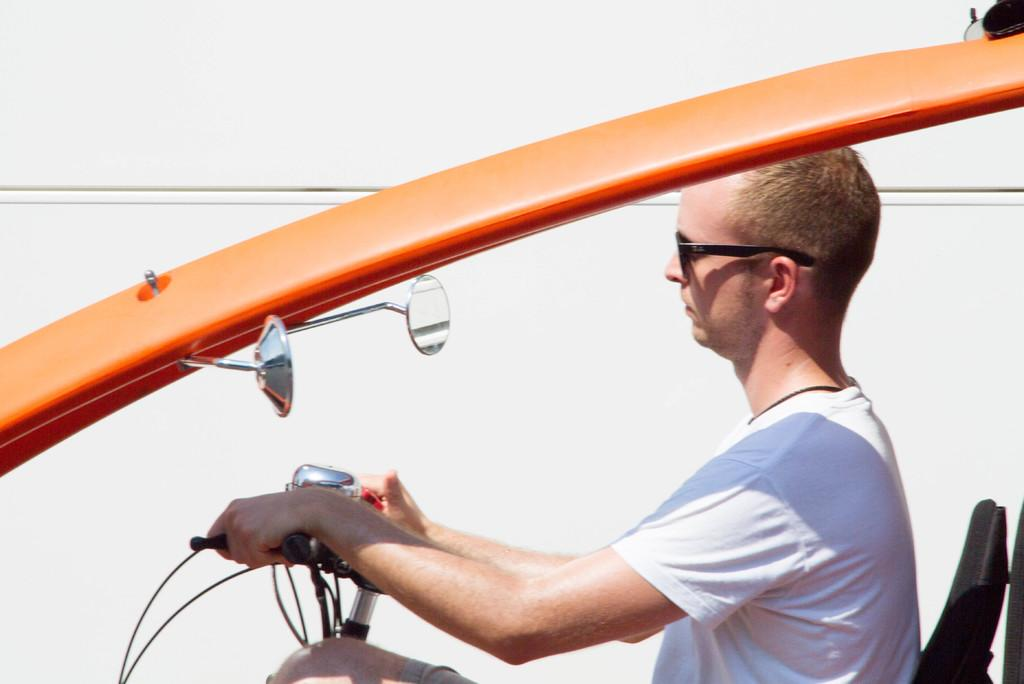What is the main subject of the image? The main subject of the image is a man. What is the man doing in the image? The man is driving a vehicle. What feature can be seen in the middle of the vehicle? There is a handle in the middle of the vehicle. How many mirrors are present in the middle of the vehicle? There are two mirrors in the middle of the vehicle. What protective gear is the man wearing? The man is wearing goggles. How many chickens are visible in the image? There are no chickens present in the image. What type of glass is used to make the vehicle's windshield? The image does not provide information about the type of glass used for the vehicle's windshield. 